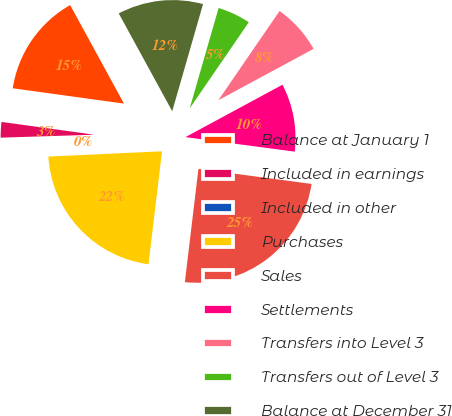Convert chart to OTSL. <chart><loc_0><loc_0><loc_500><loc_500><pie_chart><fcel>Balance at January 1<fcel>Included in earnings<fcel>Included in other<fcel>Purchases<fcel>Sales<fcel>Settlements<fcel>Transfers into Level 3<fcel>Transfers out of Level 3<fcel>Balance at December 31<nl><fcel>14.86%<fcel>2.68%<fcel>0.24%<fcel>22.36%<fcel>24.79%<fcel>9.99%<fcel>7.55%<fcel>5.11%<fcel>12.42%<nl></chart> 